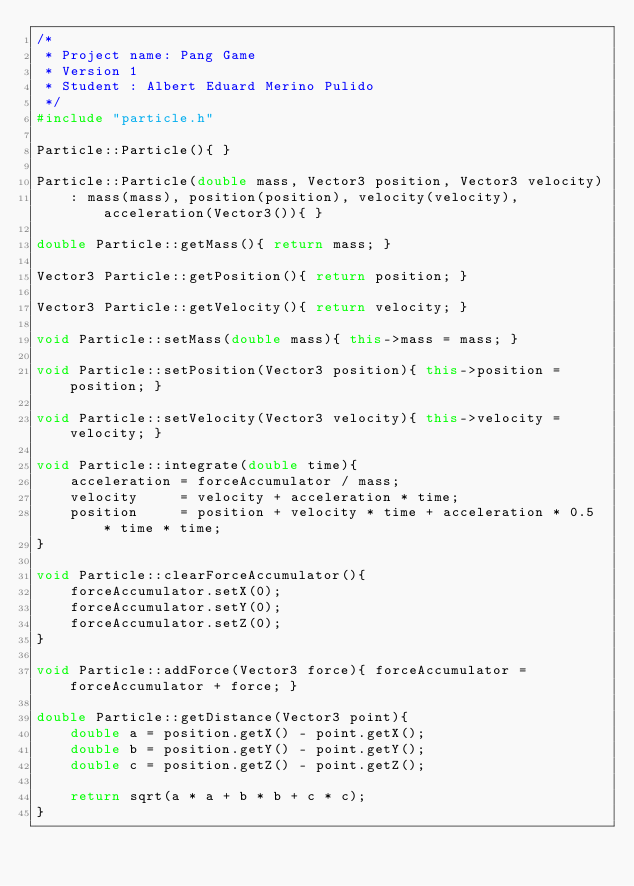<code> <loc_0><loc_0><loc_500><loc_500><_C++_>/*
 * Project name: Pang Game
 * Version 1
 * Student : Albert Eduard Merino Pulido
 */
#include "particle.h"

Particle::Particle(){ }

Particle::Particle(double mass, Vector3 position, Vector3 velocity)
    : mass(mass), position(position), velocity(velocity), acceleration(Vector3()){ }

double Particle::getMass(){ return mass; }

Vector3 Particle::getPosition(){ return position; }

Vector3 Particle::getVelocity(){ return velocity; }

void Particle::setMass(double mass){ this->mass = mass; }

void Particle::setPosition(Vector3 position){ this->position = position; }

void Particle::setVelocity(Vector3 velocity){ this->velocity = velocity; }

void Particle::integrate(double time){
    acceleration = forceAccumulator / mass;
    velocity     = velocity + acceleration * time;
    position     = position + velocity * time + acceleration * 0.5 * time * time;
}

void Particle::clearForceAccumulator(){
    forceAccumulator.setX(0);
    forceAccumulator.setY(0);
    forceAccumulator.setZ(0);
}

void Particle::addForce(Vector3 force){ forceAccumulator = forceAccumulator + force; }

double Particle::getDistance(Vector3 point){
    double a = position.getX() - point.getX();
    double b = position.getY() - point.getY();
    double c = position.getZ() - point.getZ();

    return sqrt(a * a + b * b + c * c);
}
</code> 